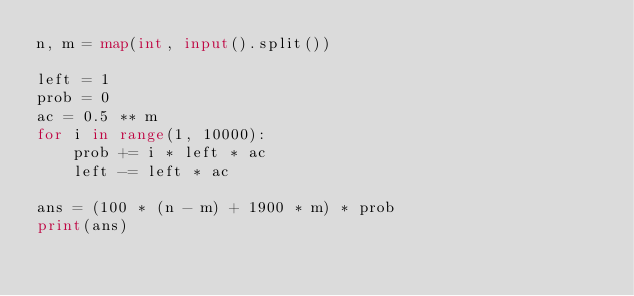<code> <loc_0><loc_0><loc_500><loc_500><_Python_>n, m = map(int, input().split())

left = 1
prob = 0
ac = 0.5 ** m
for i in range(1, 10000):
    prob += i * left * ac
    left -= left * ac

ans = (100 * (n - m) + 1900 * m) * prob
print(ans)
</code> 